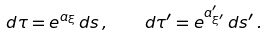Convert formula to latex. <formula><loc_0><loc_0><loc_500><loc_500>d \tau = e ^ { a _ { \xi } } \, d s \, , \quad d \tau ^ { \prime } = e ^ { a ^ { \prime } _ { \xi ^ { \prime } } } \, d s ^ { \prime } \, .</formula> 